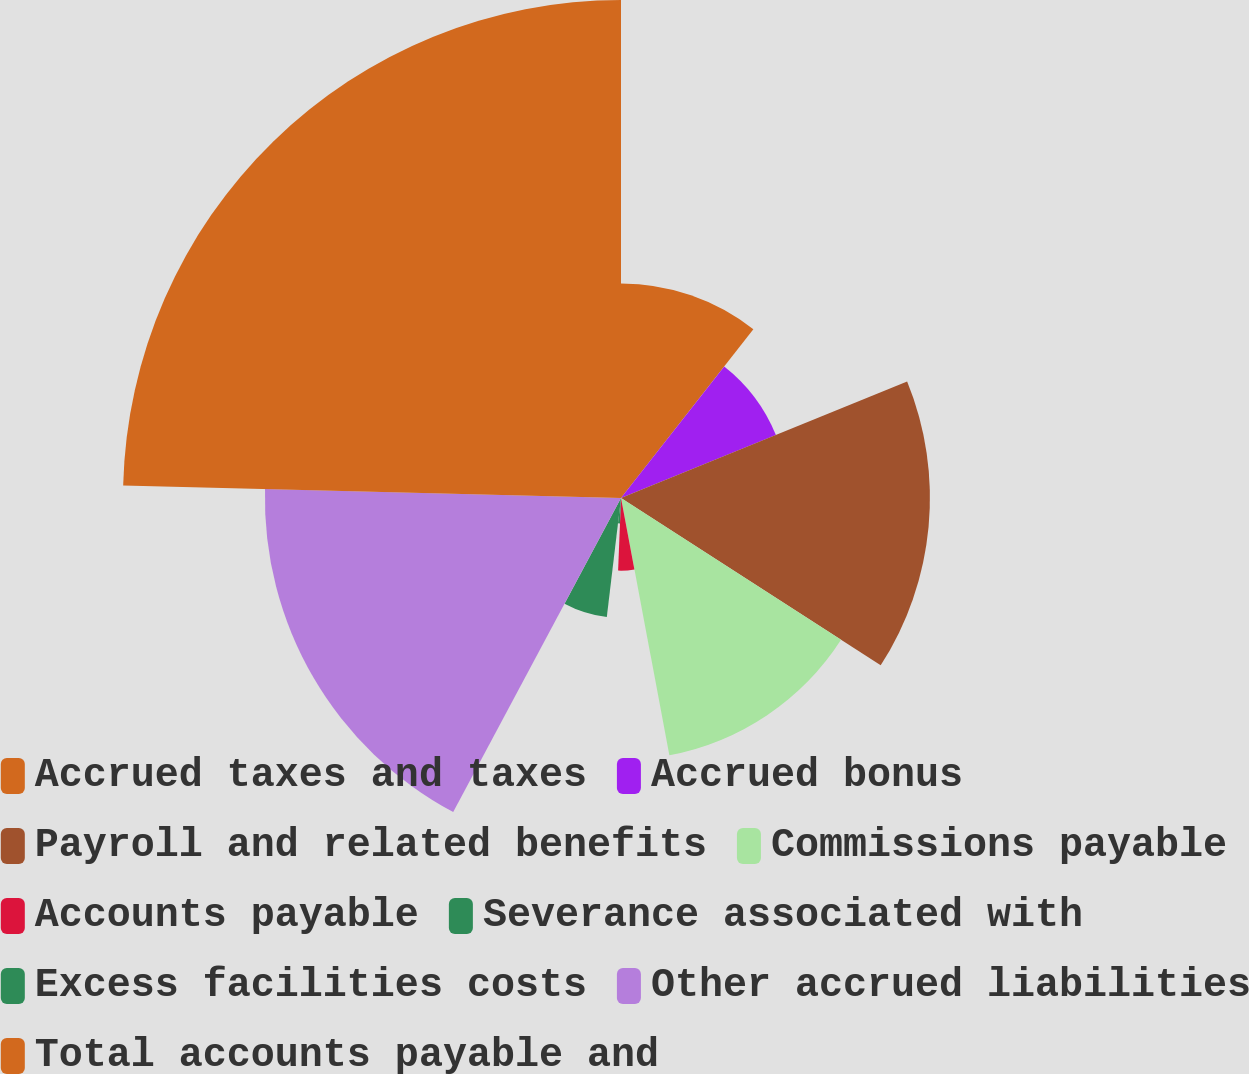Convert chart. <chart><loc_0><loc_0><loc_500><loc_500><pie_chart><fcel>Accrued taxes and taxes<fcel>Accrued bonus<fcel>Payroll and related benefits<fcel>Commissions payable<fcel>Accounts payable<fcel>Severance associated with<fcel>Excess facilities costs<fcel>Other accrued liabilities<fcel>Total accounts payable and<nl><fcel>10.59%<fcel>8.26%<fcel>15.26%<fcel>12.93%<fcel>3.59%<fcel>1.26%<fcel>5.92%<fcel>17.59%<fcel>24.6%<nl></chart> 